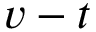<formula> <loc_0><loc_0><loc_500><loc_500>v - t</formula> 